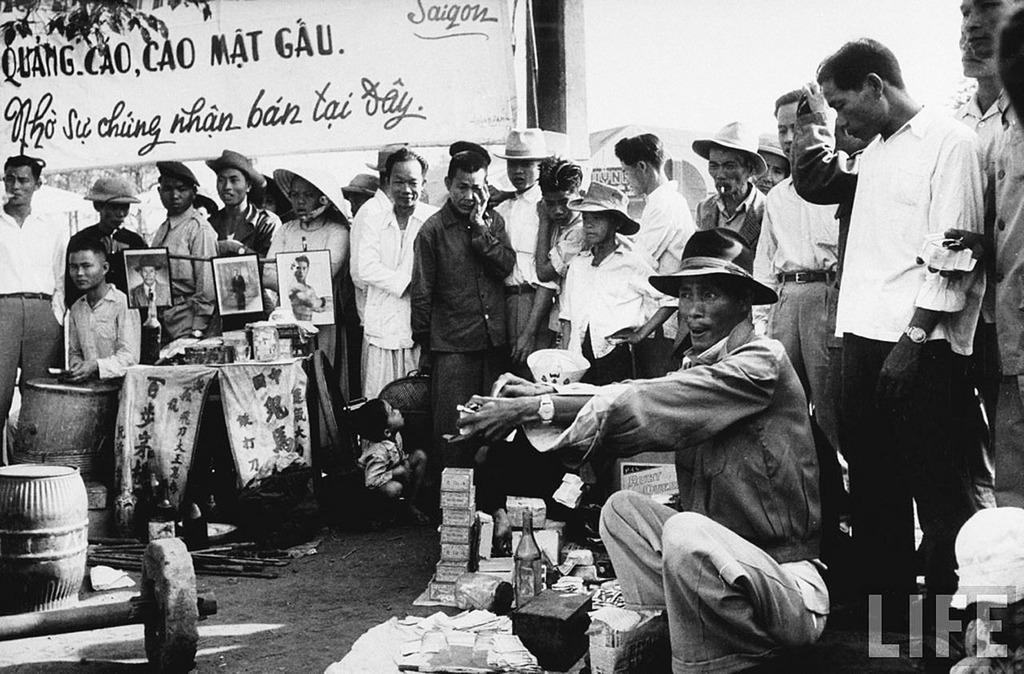Can you describe this image briefly? In this image I can see the black and white picture in which I can see few bottles, few other objects and I can see a person wearing a hat is sitting in front of these objects. I can see number of persons are standing around him, few photo frames and few other objects on the table. I can see few barrels and few objects on the ground. In the background I can see a banner, few poles, a tent, few trees and the sky. 